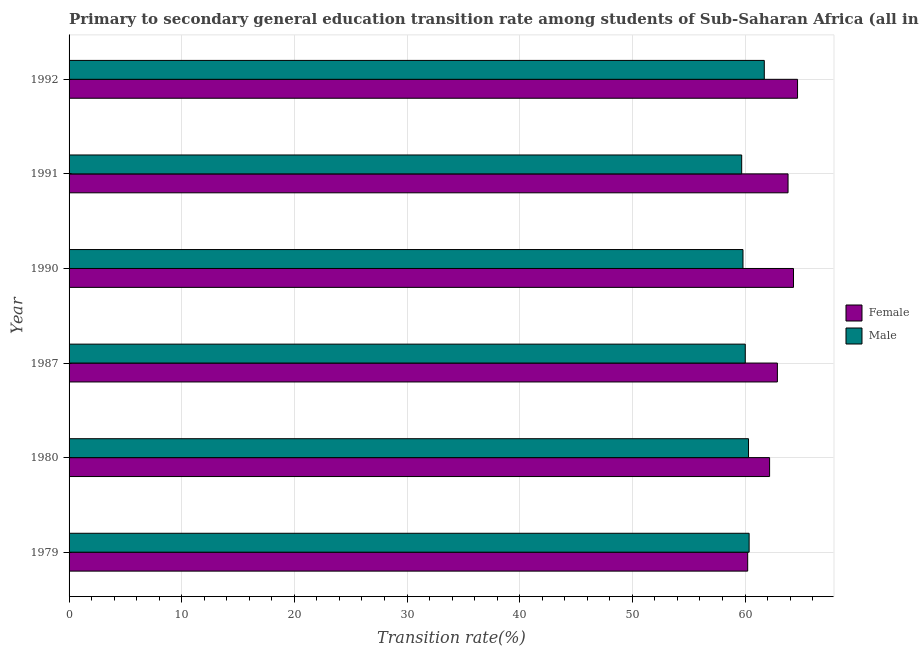How many groups of bars are there?
Give a very brief answer. 6. Are the number of bars per tick equal to the number of legend labels?
Provide a succinct answer. Yes. Are the number of bars on each tick of the Y-axis equal?
Keep it short and to the point. Yes. What is the label of the 1st group of bars from the top?
Make the answer very short. 1992. What is the transition rate among male students in 1980?
Give a very brief answer. 60.31. Across all years, what is the maximum transition rate among male students?
Ensure brevity in your answer.  61.71. Across all years, what is the minimum transition rate among male students?
Provide a short and direct response. 59.71. In which year was the transition rate among female students maximum?
Provide a succinct answer. 1992. In which year was the transition rate among male students minimum?
Keep it short and to the point. 1991. What is the total transition rate among female students in the graph?
Offer a terse response. 378.09. What is the difference between the transition rate among female students in 1990 and that in 1991?
Provide a succinct answer. 0.48. What is the difference between the transition rate among female students in 1980 and the transition rate among male students in 1987?
Your answer should be compact. 2.16. What is the average transition rate among male students per year?
Provide a succinct answer. 60.32. In the year 1990, what is the difference between the transition rate among male students and transition rate among female students?
Keep it short and to the point. -4.48. In how many years, is the transition rate among male students greater than 52 %?
Make the answer very short. 6. Is the transition rate among male students in 1987 less than that in 1992?
Provide a succinct answer. Yes. What is the difference between the highest and the second highest transition rate among female students?
Make the answer very short. 0.36. What is the difference between the highest and the lowest transition rate among female students?
Keep it short and to the point. 4.43. Is the sum of the transition rate among male students in 1987 and 1990 greater than the maximum transition rate among female students across all years?
Your answer should be compact. Yes. What does the 1st bar from the bottom in 1990 represents?
Make the answer very short. Female. How many bars are there?
Keep it short and to the point. 12. What is the difference between two consecutive major ticks on the X-axis?
Your answer should be compact. 10. Where does the legend appear in the graph?
Your answer should be compact. Center right. How are the legend labels stacked?
Ensure brevity in your answer.  Vertical. What is the title of the graph?
Offer a terse response. Primary to secondary general education transition rate among students of Sub-Saharan Africa (all income levels). What is the label or title of the X-axis?
Keep it short and to the point. Transition rate(%). What is the Transition rate(%) of Female in 1979?
Your response must be concise. 60.24. What is the Transition rate(%) in Male in 1979?
Your response must be concise. 60.37. What is the Transition rate(%) in Female in 1980?
Your response must be concise. 62.18. What is the Transition rate(%) in Male in 1980?
Offer a terse response. 60.31. What is the Transition rate(%) in Female in 1987?
Offer a terse response. 62.88. What is the Transition rate(%) of Male in 1987?
Keep it short and to the point. 60.02. What is the Transition rate(%) of Female in 1990?
Keep it short and to the point. 64.31. What is the Transition rate(%) of Male in 1990?
Give a very brief answer. 59.82. What is the Transition rate(%) of Female in 1991?
Your response must be concise. 63.82. What is the Transition rate(%) in Male in 1991?
Keep it short and to the point. 59.71. What is the Transition rate(%) of Female in 1992?
Keep it short and to the point. 64.67. What is the Transition rate(%) of Male in 1992?
Provide a short and direct response. 61.71. Across all years, what is the maximum Transition rate(%) in Female?
Make the answer very short. 64.67. Across all years, what is the maximum Transition rate(%) in Male?
Your answer should be compact. 61.71. Across all years, what is the minimum Transition rate(%) of Female?
Provide a succinct answer. 60.24. Across all years, what is the minimum Transition rate(%) of Male?
Make the answer very short. 59.71. What is the total Transition rate(%) of Female in the graph?
Provide a succinct answer. 378.09. What is the total Transition rate(%) of Male in the graph?
Your response must be concise. 361.95. What is the difference between the Transition rate(%) of Female in 1979 and that in 1980?
Your answer should be compact. -1.95. What is the difference between the Transition rate(%) of Male in 1979 and that in 1980?
Keep it short and to the point. 0.05. What is the difference between the Transition rate(%) of Female in 1979 and that in 1987?
Keep it short and to the point. -2.64. What is the difference between the Transition rate(%) of Male in 1979 and that in 1987?
Offer a very short reply. 0.34. What is the difference between the Transition rate(%) in Female in 1979 and that in 1990?
Offer a terse response. -4.07. What is the difference between the Transition rate(%) of Male in 1979 and that in 1990?
Offer a very short reply. 0.54. What is the difference between the Transition rate(%) of Female in 1979 and that in 1991?
Give a very brief answer. -3.58. What is the difference between the Transition rate(%) of Male in 1979 and that in 1991?
Ensure brevity in your answer.  0.66. What is the difference between the Transition rate(%) in Female in 1979 and that in 1992?
Your answer should be very brief. -4.43. What is the difference between the Transition rate(%) in Male in 1979 and that in 1992?
Your answer should be compact. -1.35. What is the difference between the Transition rate(%) in Female in 1980 and that in 1987?
Make the answer very short. -0.69. What is the difference between the Transition rate(%) of Male in 1980 and that in 1987?
Provide a succinct answer. 0.29. What is the difference between the Transition rate(%) in Female in 1980 and that in 1990?
Your answer should be very brief. -2.12. What is the difference between the Transition rate(%) in Male in 1980 and that in 1990?
Keep it short and to the point. 0.49. What is the difference between the Transition rate(%) of Female in 1980 and that in 1991?
Keep it short and to the point. -1.64. What is the difference between the Transition rate(%) in Male in 1980 and that in 1991?
Offer a very short reply. 0.61. What is the difference between the Transition rate(%) of Female in 1980 and that in 1992?
Provide a short and direct response. -2.48. What is the difference between the Transition rate(%) in Male in 1980 and that in 1992?
Your answer should be very brief. -1.4. What is the difference between the Transition rate(%) of Female in 1987 and that in 1990?
Give a very brief answer. -1.43. What is the difference between the Transition rate(%) of Male in 1987 and that in 1990?
Your answer should be very brief. 0.2. What is the difference between the Transition rate(%) of Female in 1987 and that in 1991?
Ensure brevity in your answer.  -0.95. What is the difference between the Transition rate(%) of Male in 1987 and that in 1991?
Offer a terse response. 0.32. What is the difference between the Transition rate(%) of Female in 1987 and that in 1992?
Your response must be concise. -1.79. What is the difference between the Transition rate(%) of Male in 1987 and that in 1992?
Provide a short and direct response. -1.69. What is the difference between the Transition rate(%) of Female in 1990 and that in 1991?
Give a very brief answer. 0.48. What is the difference between the Transition rate(%) in Male in 1990 and that in 1991?
Give a very brief answer. 0.12. What is the difference between the Transition rate(%) in Female in 1990 and that in 1992?
Your answer should be very brief. -0.36. What is the difference between the Transition rate(%) in Male in 1990 and that in 1992?
Give a very brief answer. -1.89. What is the difference between the Transition rate(%) of Female in 1991 and that in 1992?
Provide a succinct answer. -0.84. What is the difference between the Transition rate(%) in Male in 1991 and that in 1992?
Provide a short and direct response. -2.01. What is the difference between the Transition rate(%) of Female in 1979 and the Transition rate(%) of Male in 1980?
Your answer should be very brief. -0.07. What is the difference between the Transition rate(%) in Female in 1979 and the Transition rate(%) in Male in 1987?
Make the answer very short. 0.21. What is the difference between the Transition rate(%) in Female in 1979 and the Transition rate(%) in Male in 1990?
Your response must be concise. 0.42. What is the difference between the Transition rate(%) in Female in 1979 and the Transition rate(%) in Male in 1991?
Your answer should be very brief. 0.53. What is the difference between the Transition rate(%) in Female in 1979 and the Transition rate(%) in Male in 1992?
Ensure brevity in your answer.  -1.47. What is the difference between the Transition rate(%) of Female in 1980 and the Transition rate(%) of Male in 1987?
Offer a terse response. 2.16. What is the difference between the Transition rate(%) of Female in 1980 and the Transition rate(%) of Male in 1990?
Provide a succinct answer. 2.36. What is the difference between the Transition rate(%) of Female in 1980 and the Transition rate(%) of Male in 1991?
Provide a short and direct response. 2.48. What is the difference between the Transition rate(%) in Female in 1980 and the Transition rate(%) in Male in 1992?
Offer a terse response. 0.47. What is the difference between the Transition rate(%) in Female in 1987 and the Transition rate(%) in Male in 1990?
Provide a short and direct response. 3.05. What is the difference between the Transition rate(%) in Female in 1987 and the Transition rate(%) in Male in 1991?
Give a very brief answer. 3.17. What is the difference between the Transition rate(%) of Female in 1987 and the Transition rate(%) of Male in 1992?
Provide a short and direct response. 1.16. What is the difference between the Transition rate(%) of Female in 1990 and the Transition rate(%) of Male in 1991?
Make the answer very short. 4.6. What is the difference between the Transition rate(%) in Female in 1990 and the Transition rate(%) in Male in 1992?
Your answer should be compact. 2.59. What is the difference between the Transition rate(%) of Female in 1991 and the Transition rate(%) of Male in 1992?
Provide a short and direct response. 2.11. What is the average Transition rate(%) of Female per year?
Offer a very short reply. 63.02. What is the average Transition rate(%) of Male per year?
Your response must be concise. 60.32. In the year 1979, what is the difference between the Transition rate(%) in Female and Transition rate(%) in Male?
Make the answer very short. -0.13. In the year 1980, what is the difference between the Transition rate(%) of Female and Transition rate(%) of Male?
Offer a very short reply. 1.87. In the year 1987, what is the difference between the Transition rate(%) in Female and Transition rate(%) in Male?
Offer a very short reply. 2.85. In the year 1990, what is the difference between the Transition rate(%) of Female and Transition rate(%) of Male?
Make the answer very short. 4.48. In the year 1991, what is the difference between the Transition rate(%) of Female and Transition rate(%) of Male?
Provide a succinct answer. 4.12. In the year 1992, what is the difference between the Transition rate(%) of Female and Transition rate(%) of Male?
Your response must be concise. 2.95. What is the ratio of the Transition rate(%) of Female in 1979 to that in 1980?
Your response must be concise. 0.97. What is the ratio of the Transition rate(%) of Female in 1979 to that in 1987?
Keep it short and to the point. 0.96. What is the ratio of the Transition rate(%) in Female in 1979 to that in 1990?
Your response must be concise. 0.94. What is the ratio of the Transition rate(%) in Male in 1979 to that in 1990?
Your answer should be very brief. 1.01. What is the ratio of the Transition rate(%) in Female in 1979 to that in 1991?
Provide a succinct answer. 0.94. What is the ratio of the Transition rate(%) of Male in 1979 to that in 1991?
Keep it short and to the point. 1.01. What is the ratio of the Transition rate(%) of Female in 1979 to that in 1992?
Provide a succinct answer. 0.93. What is the ratio of the Transition rate(%) of Male in 1979 to that in 1992?
Provide a succinct answer. 0.98. What is the ratio of the Transition rate(%) in Male in 1980 to that in 1987?
Your answer should be compact. 1. What is the ratio of the Transition rate(%) of Female in 1980 to that in 1990?
Offer a very short reply. 0.97. What is the ratio of the Transition rate(%) of Male in 1980 to that in 1990?
Provide a succinct answer. 1.01. What is the ratio of the Transition rate(%) in Female in 1980 to that in 1991?
Your answer should be compact. 0.97. What is the ratio of the Transition rate(%) of Male in 1980 to that in 1991?
Ensure brevity in your answer.  1.01. What is the ratio of the Transition rate(%) in Female in 1980 to that in 1992?
Offer a very short reply. 0.96. What is the ratio of the Transition rate(%) in Male in 1980 to that in 1992?
Your answer should be compact. 0.98. What is the ratio of the Transition rate(%) of Female in 1987 to that in 1990?
Keep it short and to the point. 0.98. What is the ratio of the Transition rate(%) of Female in 1987 to that in 1991?
Offer a terse response. 0.99. What is the ratio of the Transition rate(%) in Female in 1987 to that in 1992?
Provide a succinct answer. 0.97. What is the ratio of the Transition rate(%) in Male in 1987 to that in 1992?
Ensure brevity in your answer.  0.97. What is the ratio of the Transition rate(%) in Female in 1990 to that in 1991?
Your answer should be compact. 1.01. What is the ratio of the Transition rate(%) of Male in 1990 to that in 1991?
Give a very brief answer. 1. What is the ratio of the Transition rate(%) of Female in 1990 to that in 1992?
Your answer should be very brief. 0.99. What is the ratio of the Transition rate(%) of Male in 1990 to that in 1992?
Your answer should be compact. 0.97. What is the ratio of the Transition rate(%) in Female in 1991 to that in 1992?
Your answer should be compact. 0.99. What is the ratio of the Transition rate(%) in Male in 1991 to that in 1992?
Provide a succinct answer. 0.97. What is the difference between the highest and the second highest Transition rate(%) of Female?
Provide a succinct answer. 0.36. What is the difference between the highest and the second highest Transition rate(%) in Male?
Keep it short and to the point. 1.35. What is the difference between the highest and the lowest Transition rate(%) in Female?
Give a very brief answer. 4.43. What is the difference between the highest and the lowest Transition rate(%) in Male?
Provide a succinct answer. 2.01. 